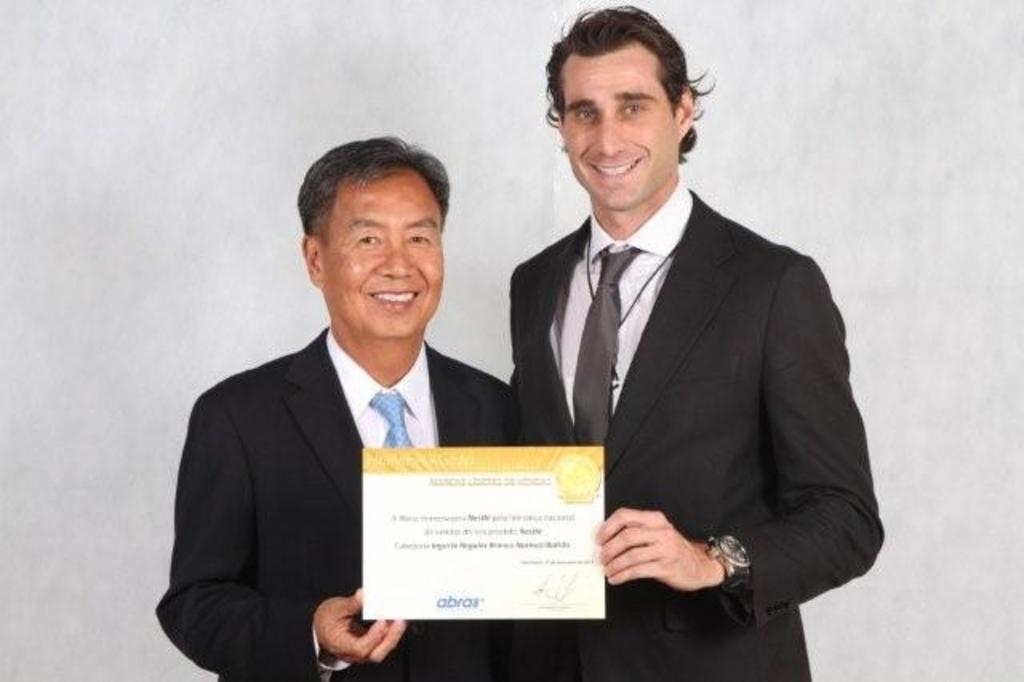How many people are in the image? There are two persons in the image. What are the persons doing in the image? The persons are standing. What are the persons wearing in the image? The persons are wearing suits. What are the persons holding in the image? The persons are holding certification cards. What message does the queen deliver to the persons in the image? There is no queen present in the image, so it is not possible to determine any message she might deliver. 